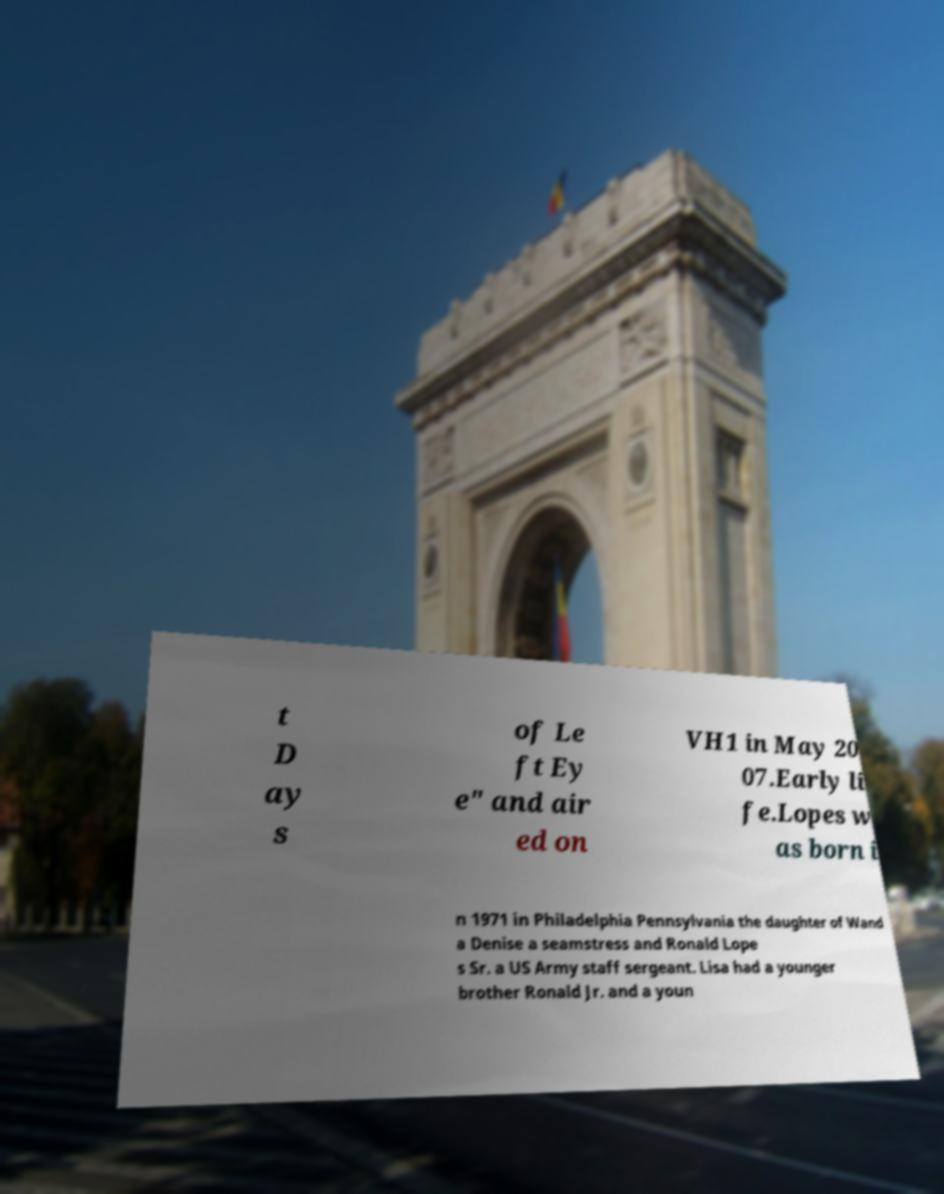For documentation purposes, I need the text within this image transcribed. Could you provide that? t D ay s of Le ft Ey e" and air ed on VH1 in May 20 07.Early li fe.Lopes w as born i n 1971 in Philadelphia Pennsylvania the daughter of Wand a Denise a seamstress and Ronald Lope s Sr. a US Army staff sergeant. Lisa had a younger brother Ronald Jr. and a youn 